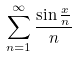Convert formula to latex. <formula><loc_0><loc_0><loc_500><loc_500>\sum _ { n = 1 } ^ { \infty } \frac { \sin \frac { x } { n } } { n }</formula> 